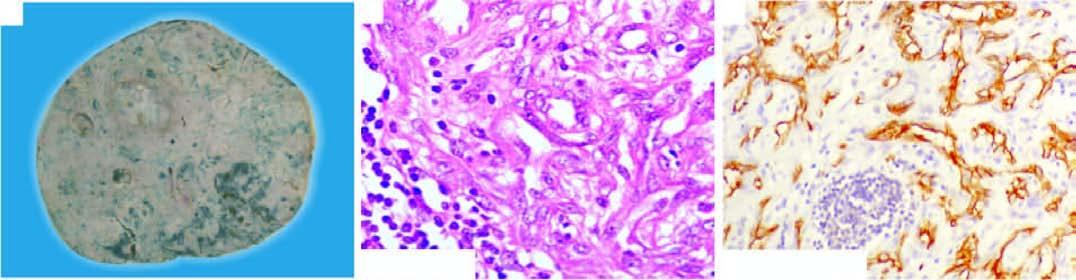what show positive staining for endothelial marker, cd34?
Answer the question using a single word or phrase. These tumour cells 